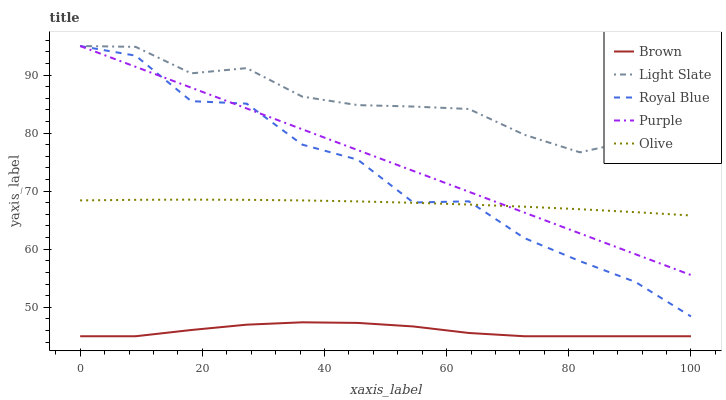Does Brown have the minimum area under the curve?
Answer yes or no. Yes. Does Light Slate have the maximum area under the curve?
Answer yes or no. Yes. Does Olive have the minimum area under the curve?
Answer yes or no. No. Does Olive have the maximum area under the curve?
Answer yes or no. No. Is Purple the smoothest?
Answer yes or no. Yes. Is Royal Blue the roughest?
Answer yes or no. Yes. Is Brown the smoothest?
Answer yes or no. No. Is Brown the roughest?
Answer yes or no. No. Does Brown have the lowest value?
Answer yes or no. Yes. Does Olive have the lowest value?
Answer yes or no. No. Does Royal Blue have the highest value?
Answer yes or no. Yes. Does Olive have the highest value?
Answer yes or no. No. Is Brown less than Royal Blue?
Answer yes or no. Yes. Is Purple greater than Brown?
Answer yes or no. Yes. Does Light Slate intersect Royal Blue?
Answer yes or no. Yes. Is Light Slate less than Royal Blue?
Answer yes or no. No. Is Light Slate greater than Royal Blue?
Answer yes or no. No. Does Brown intersect Royal Blue?
Answer yes or no. No. 